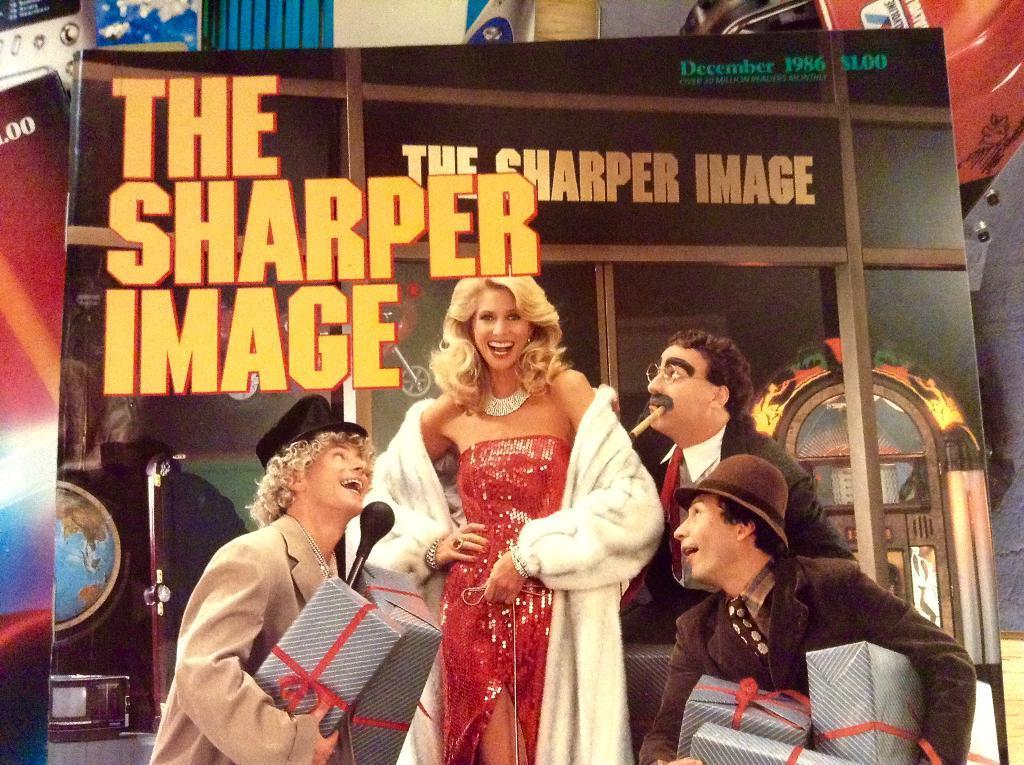In one or two sentences, can you explain what this image depicts? In the center of the picture there is a poster, on poster there is a woman and three men, the men are holding gift boxes. In the background there are other posters. In the center of the picture there is text on the poster. 